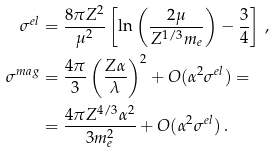Convert formula to latex. <formula><loc_0><loc_0><loc_500><loc_500>\sigma ^ { e l } & = \frac { 8 \pi Z ^ { 2 } } { \mu ^ { 2 } } \left [ \ln \left ( \frac { 2 \mu } { Z ^ { 1 / 3 } m _ { e } } \right ) - \frac { 3 } { 4 } \right ] \, , \\ \sigma ^ { m a g } & = \frac { 4 \pi } { 3 } \left ( \frac { Z \alpha } { \lambda } \right ) ^ { 2 } + O ( \alpha ^ { 2 } \sigma ^ { e l } ) = \\ & = \frac { 4 \pi Z ^ { 4 / 3 } \alpha ^ { 2 } } { 3 m _ { e } ^ { 2 } } + O ( \alpha ^ { 2 } \sigma ^ { e l } ) \, .</formula> 